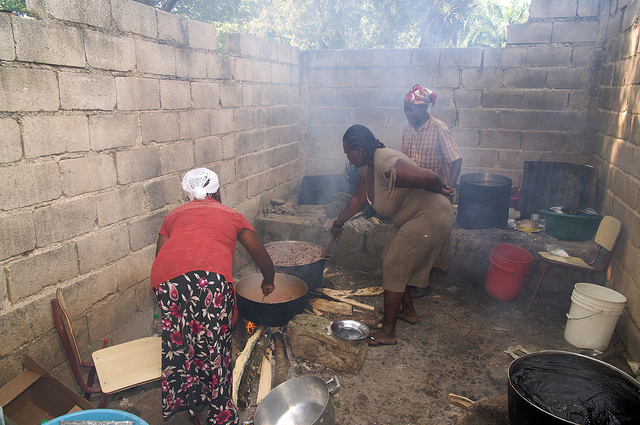<image>What country is this? I am not sure which country this is. The answers suggest several possibilities including Tanzania, Nigeria, South Africa, Romania, Haiti, Kenya, or Jamaica. What country is this? It is ambiguous which country is shown in the image. It can be Tanzania, Nigeria, South Africa, Romania, Haiti, Kenya, or Jamaica. 